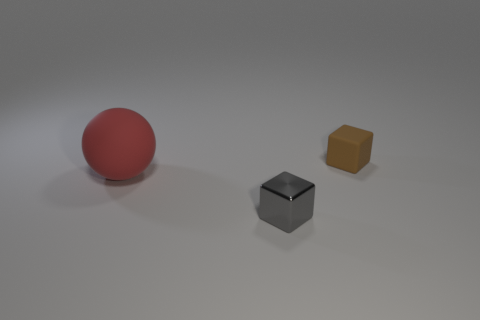What shape is the brown rubber thing that is the same size as the gray metallic thing?
Your response must be concise. Cube. What number of small brown matte things are behind the matte ball?
Provide a short and direct response. 1. What number of objects are either brown cubes or big red objects?
Offer a terse response. 2. There is a thing that is both right of the red matte ball and in front of the small matte block; what shape is it?
Your response must be concise. Cube. What number of yellow metal objects are there?
Provide a short and direct response. 0. What color is the cube that is made of the same material as the big red thing?
Your answer should be very brief. Brown. Are there more objects than yellow spheres?
Make the answer very short. Yes. There is a thing that is both to the left of the brown object and behind the tiny gray shiny object; how big is it?
Give a very brief answer. Large. Are there an equal number of tiny things behind the brown object and tiny cyan blocks?
Offer a terse response. Yes. Do the red rubber sphere and the gray metallic object have the same size?
Provide a short and direct response. No. 